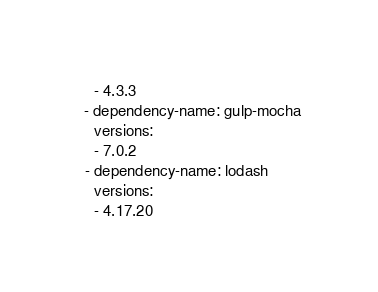Convert code to text. <code><loc_0><loc_0><loc_500><loc_500><_YAML_>    - 4.3.3
  - dependency-name: gulp-mocha
    versions:
    - 7.0.2
  - dependency-name: lodash
    versions:
    - 4.17.20
</code> 